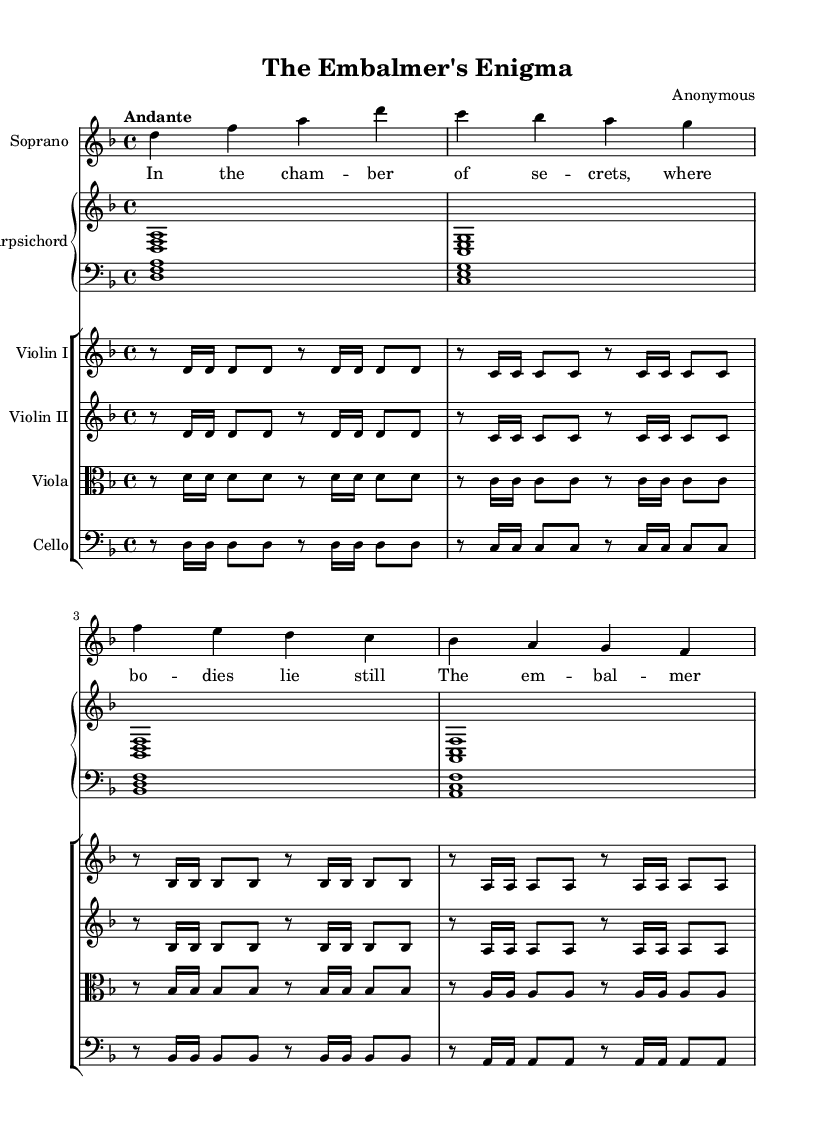What is the key signature of this music? The key signature indicates that there is one flat (B♭), which is characteristic of D minor. Thus, D minor is the key signature.
Answer: D minor What is the time signature of this piece? The time signature is indicated at the beginning and shows 4 beats per measure, which corresponds to common time. This is represented by the 4/4 notation.
Answer: 4/4 What tempo is indicated for this piece? The tempo marking at the beginning states "Andante," which indicates a moderate walking pace. This is a specific term used in music to define tempo.
Answer: Andante How many parts are there in the ensemble indicated? The score shows a total of five distinct parts or staves (Soprano, Violin I, Violin II, Viola, Cello, and Harpsichord). Each part is notated separately, leading to a total of five parts.
Answer: Five What is the melodic structure noted in the soprano line? The soprano line consists of a relatively simple melodic contour with rising and falling notes. Observing the pitches, we see a pattern of movement, typical in a vocal line of Baroque music, which alternates between small intervals and leaps.
Answer: Simple melodic contour What kind of harmony is primarily used in this piece? The harmony is primarily built on triads, as indicated by the intervals formed with the chords in the harpsichord part. The use of root position and first inversion triads is typical in Baroque music, creating a rich harmonic texture.
Answer: Triadic harmony 